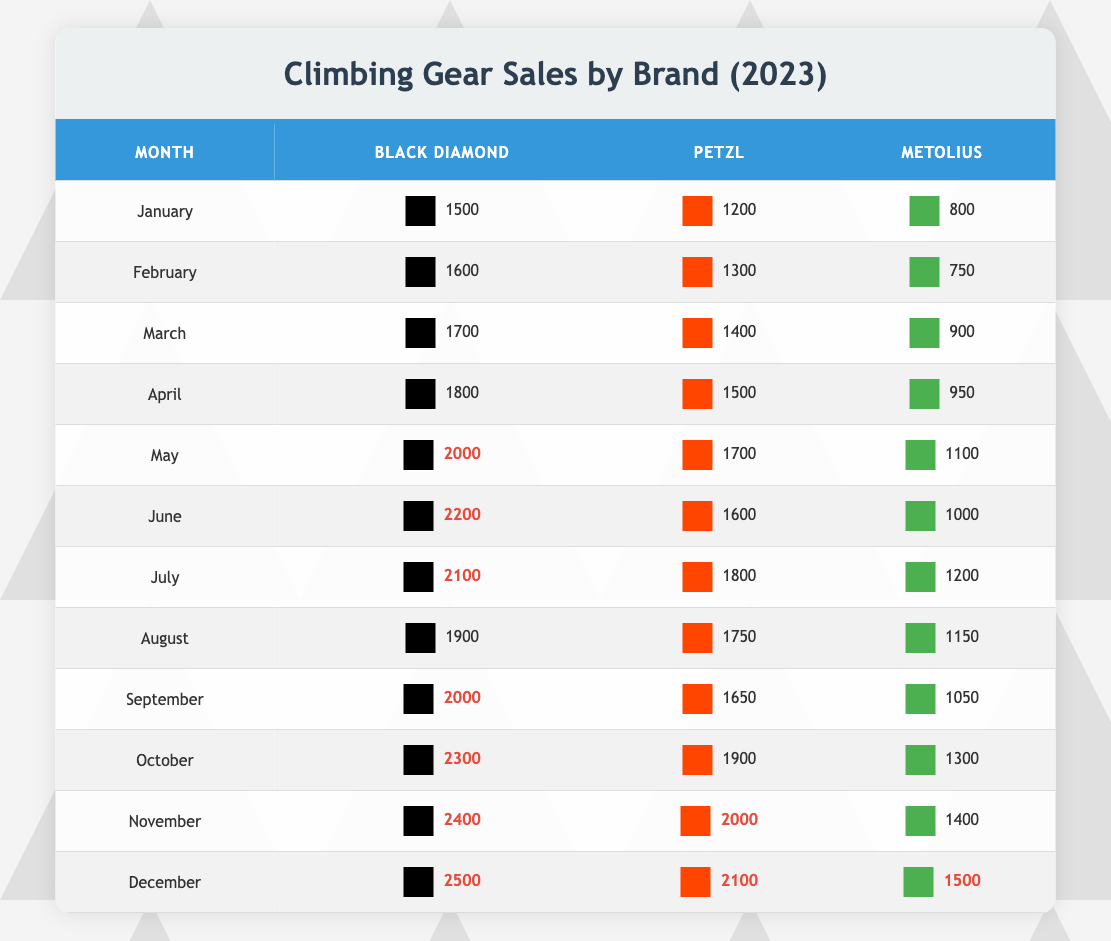What was the highest sales month for Black Diamond? By examining the sales data for Black Diamond, December shows the highest sales figure of 2500.
Answer: December Which brand had the lowest sales in February? In February, Metolius had the lowest sales with a total of 750.
Answer: Metolius What is the total sales for Petzl from May to August? Adding up the sales for Petzl during May (1700), June (1600), July (1800), and August (1750) gives (1700 + 1600 + 1800 + 1750) = 6850.
Answer: 6850 Did Metolius have more than 1000 sales during the months of March to June? Checking each month from March to June, Metolius had sales of 900, 950, 1100, and 1000 respectively. Only in May did they exceed 1000 sales.
Answer: No What is the average sales for Black Diamond over the entire year? Summing the monthly sales for Black Diamond gives (1500 + 1600 + 1700 + 1800 + 2000 + 2200 + 2100 + 1900 + 2000 + 2300 + 2400 + 2500) = 23900, with 12 months in total, leading to an average of 23900/12 ≈ 1991.67.
Answer: 1991.67 Which month showed a significant drop in Metolius sales compared to the previous month? Comparing sales, July had 1200 while June had 1000, showing an increase; however, the significant drop occurs from April to May where sales fell from 950 to 1100.
Answer: April to May How many months did Black Diamond sell more than 2000 units? Reviewing the sales data for Black Diamond, they sold more than 2000 units in June (2200), July (2100), October (2300), November (2400), and December (2500), totaling 5 months.
Answer: 5 months Was there any month where all brands had sales above 1800? Examining the data, the months of October, November, and December show all brands exceeding 1800 units in sales, indicating that multiple brands surpassed this threshold in three separate months.
Answer: Yes What was the total sales for all brands in January? Adding the sales for each brand in January gives (1500 for Black Diamond + 1200 for Petzl + 800 for Metolius) = 3500.
Answer: 3500 